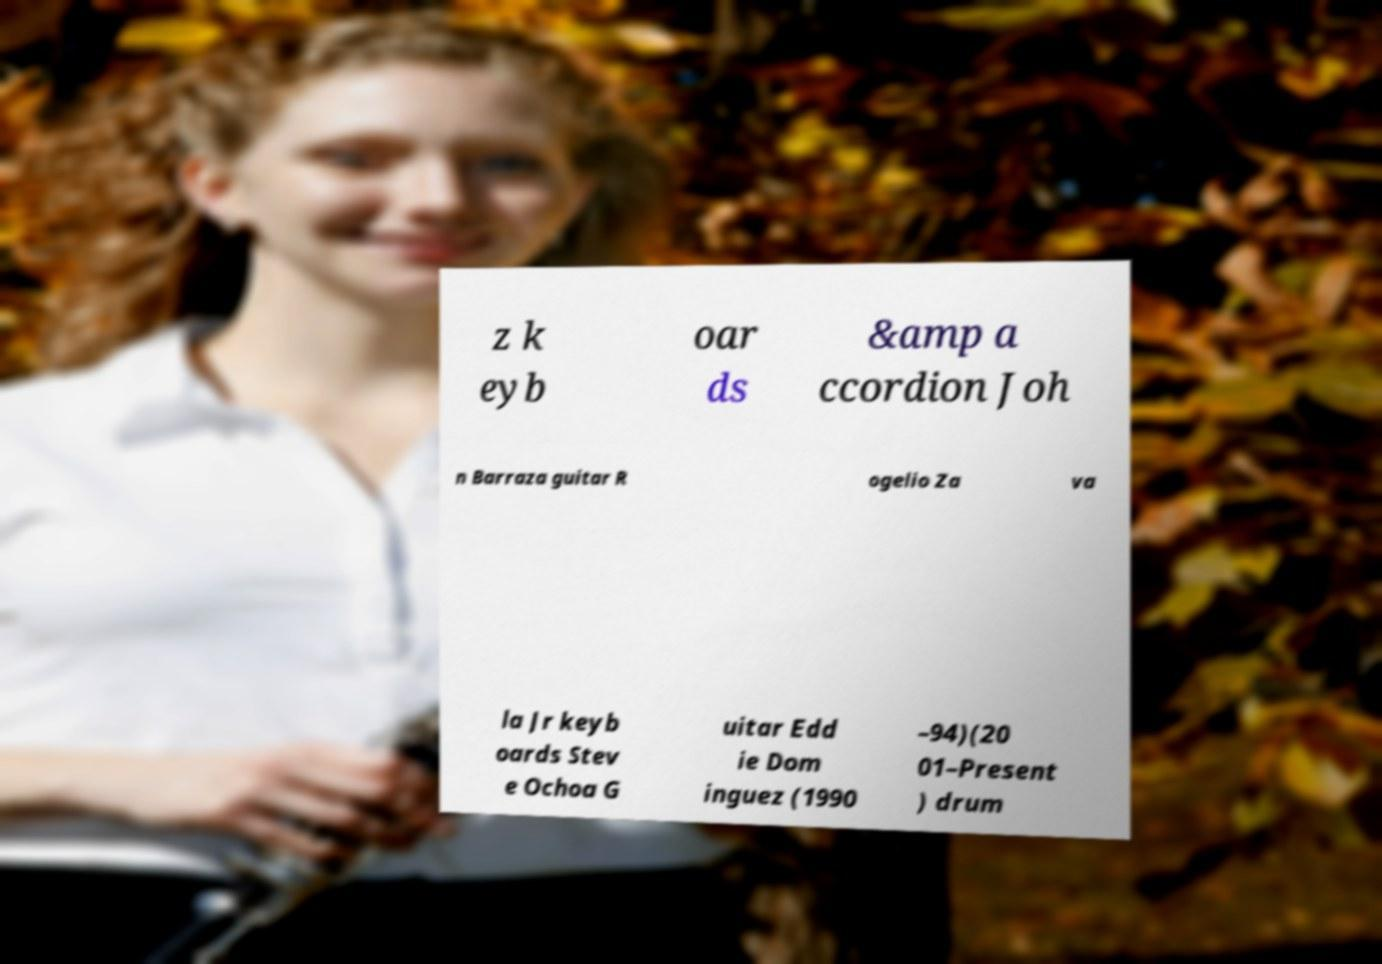Please identify and transcribe the text found in this image. z k eyb oar ds &amp a ccordion Joh n Barraza guitar R ogelio Za va la Jr keyb oards Stev e Ochoa G uitar Edd ie Dom inguez (1990 –94)(20 01–Present ) drum 